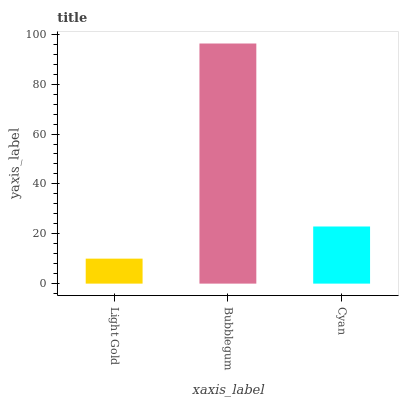Is Light Gold the minimum?
Answer yes or no. Yes. Is Bubblegum the maximum?
Answer yes or no. Yes. Is Cyan the minimum?
Answer yes or no. No. Is Cyan the maximum?
Answer yes or no. No. Is Bubblegum greater than Cyan?
Answer yes or no. Yes. Is Cyan less than Bubblegum?
Answer yes or no. Yes. Is Cyan greater than Bubblegum?
Answer yes or no. No. Is Bubblegum less than Cyan?
Answer yes or no. No. Is Cyan the high median?
Answer yes or no. Yes. Is Cyan the low median?
Answer yes or no. Yes. Is Bubblegum the high median?
Answer yes or no. No. Is Light Gold the low median?
Answer yes or no. No. 